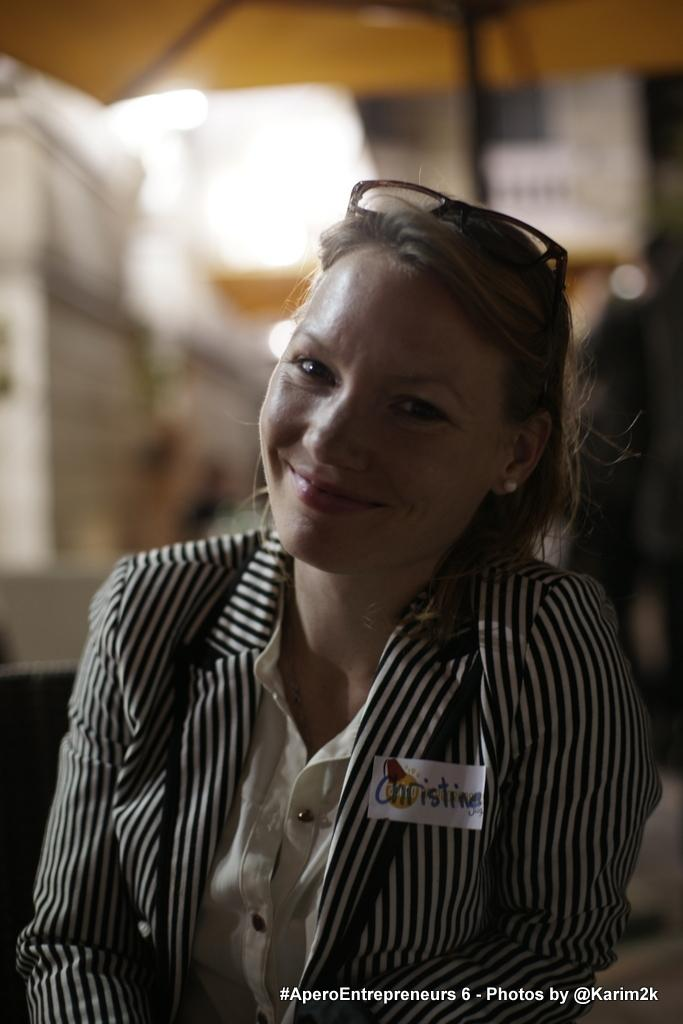Who is the main subject in the image? There is a lady in the center of the image. What is the lady doing in the image? The lady is smiling. What is the lady wearing in the image? The lady is wearing a jacket. What can be seen in the background of the image? There is a wall in the background of the image. What type of cracker is the lady holding in the image? There is no cracker present in the image; the lady is not holding any object. 